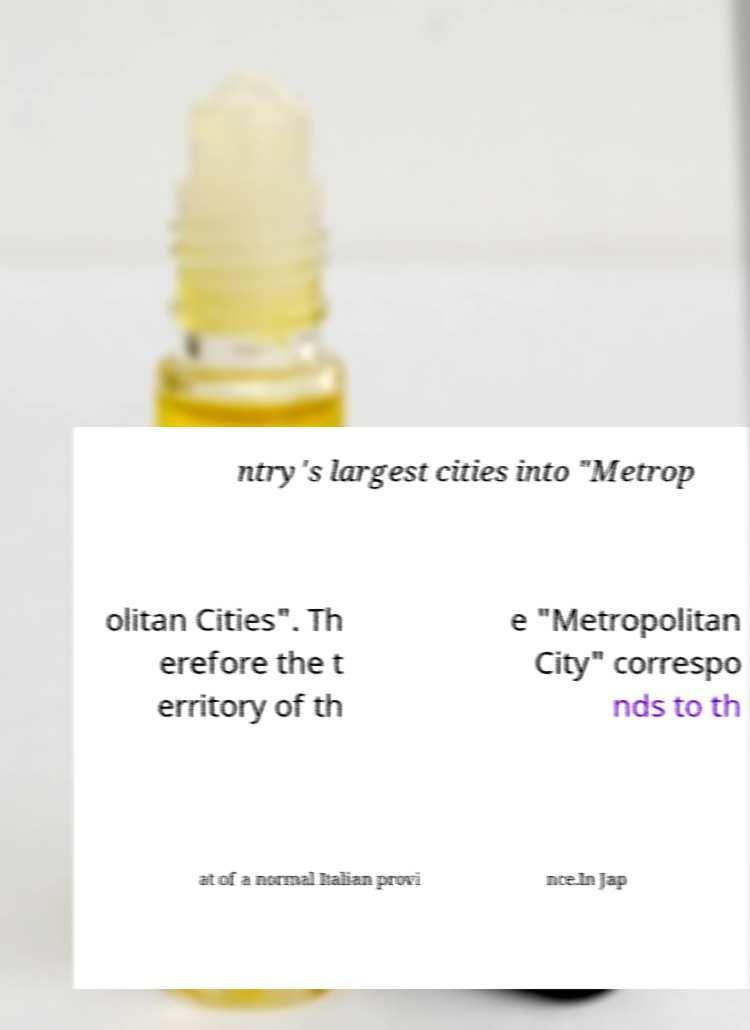For documentation purposes, I need the text within this image transcribed. Could you provide that? ntry's largest cities into "Metrop olitan Cities". Th erefore the t erritory of th e "Metropolitan City" correspo nds to th at of a normal Italian provi nce.In Jap 